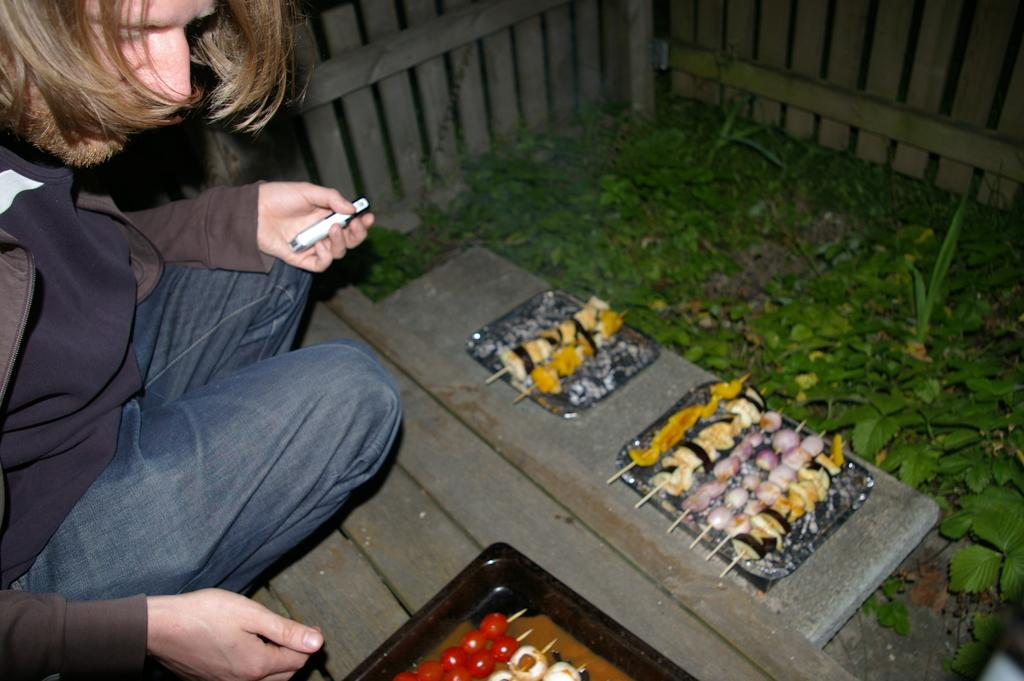What is the main subject in the image? There is a person in the image. What objects are present in the image that might be used for serving or holding food? There are trays in the image. What type of food can be seen in the image? There are food items in the image. What type of vegetation is present in the image? There are plants in the image. What type of barrier can be seen in the image? There is a fence in the image. What type of agreement can be seen in the image? There is no agreement present in the image; it is a visual representation of a person, trays, food items, plants, and a fence. How does the fog affect the visibility in the image? There is no fog present in the image; it is a clear visual representation of the scene. 